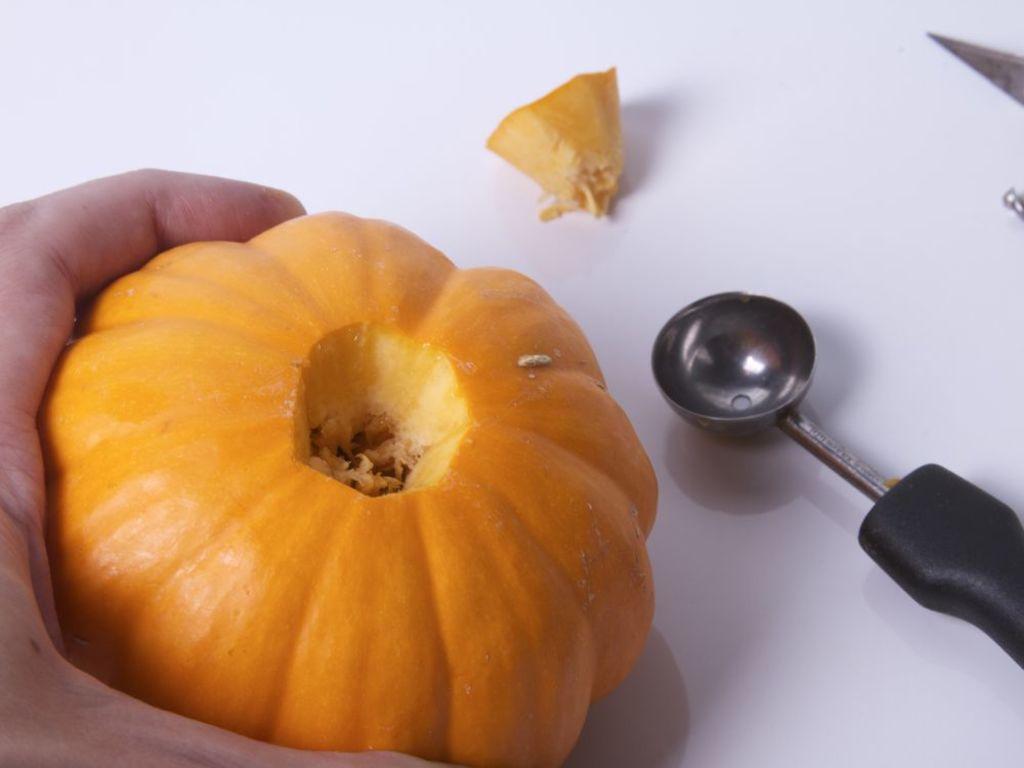Please provide a concise description of this image. In this picture we can see a spoon, knife, a piece of pumpkin, a person's hand and holding a pumpkin on the surface. 